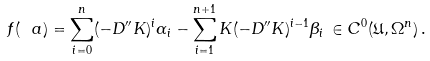<formula> <loc_0><loc_0><loc_500><loc_500>f ( \ a ) = \sum _ { i = 0 } ^ { n } ( - D ^ { \prime \prime } K ) ^ { i } \alpha _ { i } - \sum _ { i = 1 } ^ { n + 1 } K ( - D ^ { \prime \prime } K ) ^ { i - 1 } \beta _ { i } \, \in C ^ { 0 } ( { \mathfrak U } , \Omega ^ { n } ) \, .</formula> 